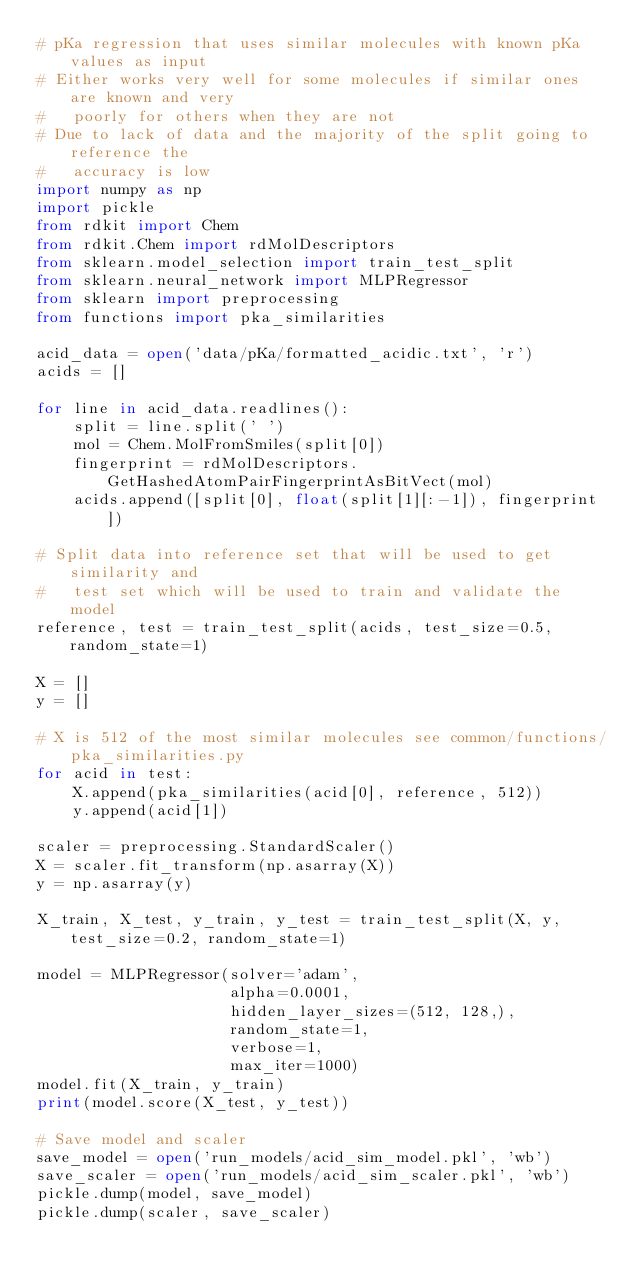<code> <loc_0><loc_0><loc_500><loc_500><_Python_># pKa regression that uses similar molecules with known pKa values as input
# Either works very well for some molecules if similar ones are known and very
#   poorly for others when they are not
# Due to lack of data and the majority of the split going to reference the
#   accuracy is low
import numpy as np
import pickle
from rdkit import Chem
from rdkit.Chem import rdMolDescriptors
from sklearn.model_selection import train_test_split
from sklearn.neural_network import MLPRegressor
from sklearn import preprocessing
from functions import pka_similarities

acid_data = open('data/pKa/formatted_acidic.txt', 'r')
acids = []

for line in acid_data.readlines():
    split = line.split(' ')
    mol = Chem.MolFromSmiles(split[0])
    fingerprint = rdMolDescriptors.GetHashedAtomPairFingerprintAsBitVect(mol)
    acids.append([split[0], float(split[1][:-1]), fingerprint])

# Split data into reference set that will be used to get similarity and
#   test set which will be used to train and validate the model
reference, test = train_test_split(acids, test_size=0.5, random_state=1)

X = []
y = []

# X is 512 of the most similar molecules see common/functions/pka_similarities.py
for acid in test:
    X.append(pka_similarities(acid[0], reference, 512))
    y.append(acid[1])

scaler = preprocessing.StandardScaler()
X = scaler.fit_transform(np.asarray(X))
y = np.asarray(y)

X_train, X_test, y_train, y_test = train_test_split(X, y, test_size=0.2, random_state=1)

model = MLPRegressor(solver='adam',
                     alpha=0.0001,
                     hidden_layer_sizes=(512, 128,),
                     random_state=1,
                     verbose=1,
                     max_iter=1000)
model.fit(X_train, y_train)
print(model.score(X_test, y_test))

# Save model and scaler
save_model = open('run_models/acid_sim_model.pkl', 'wb')
save_scaler = open('run_models/acid_sim_scaler.pkl', 'wb')
pickle.dump(model, save_model)
pickle.dump(scaler, save_scaler)</code> 